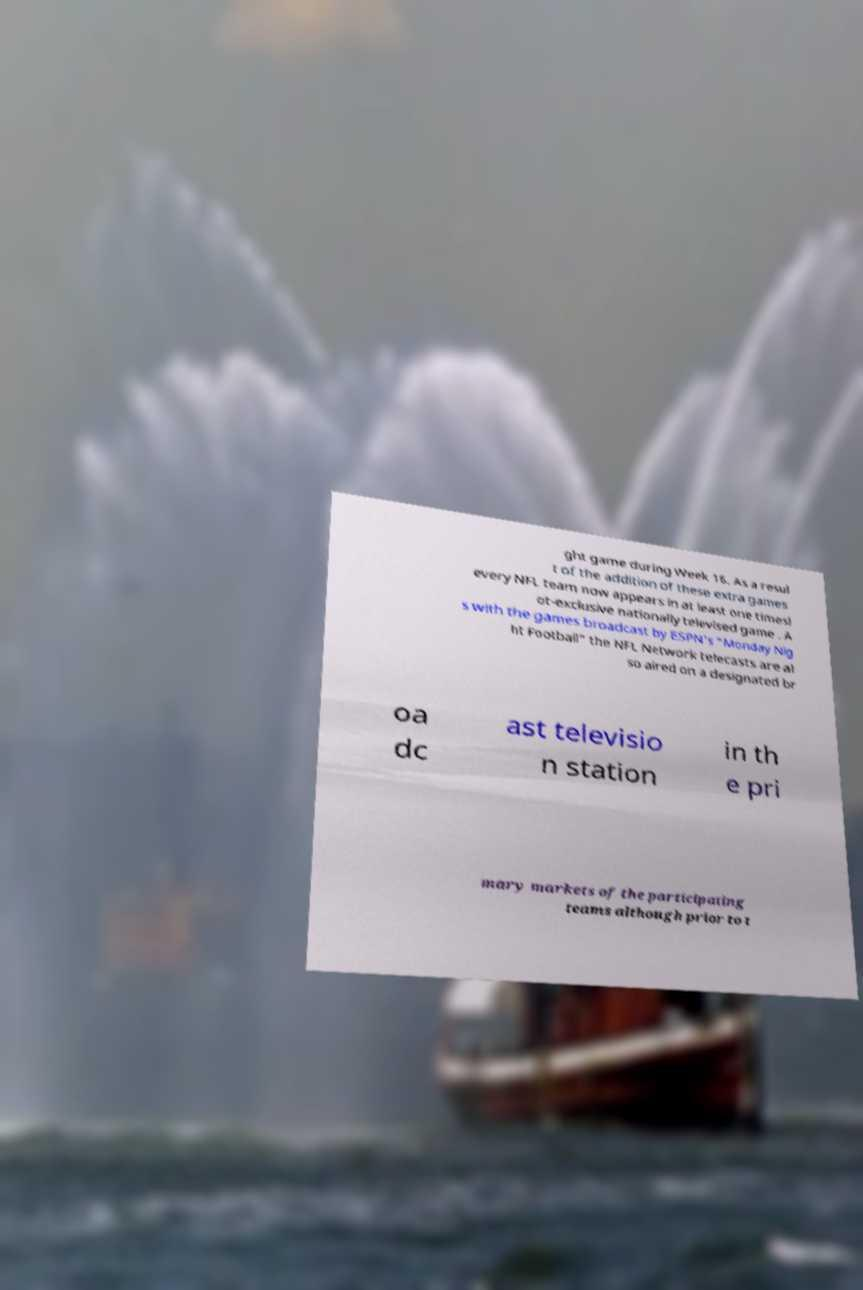Can you accurately transcribe the text from the provided image for me? ght game during Week 16. As a resul t of the addition of these extra games every NFL team now appears in at least one timesl ot-exclusive nationally televised game . A s with the games broadcast by ESPN's "Monday Nig ht Football" the NFL Network telecasts are al so aired on a designated br oa dc ast televisio n station in th e pri mary markets of the participating teams although prior to t 